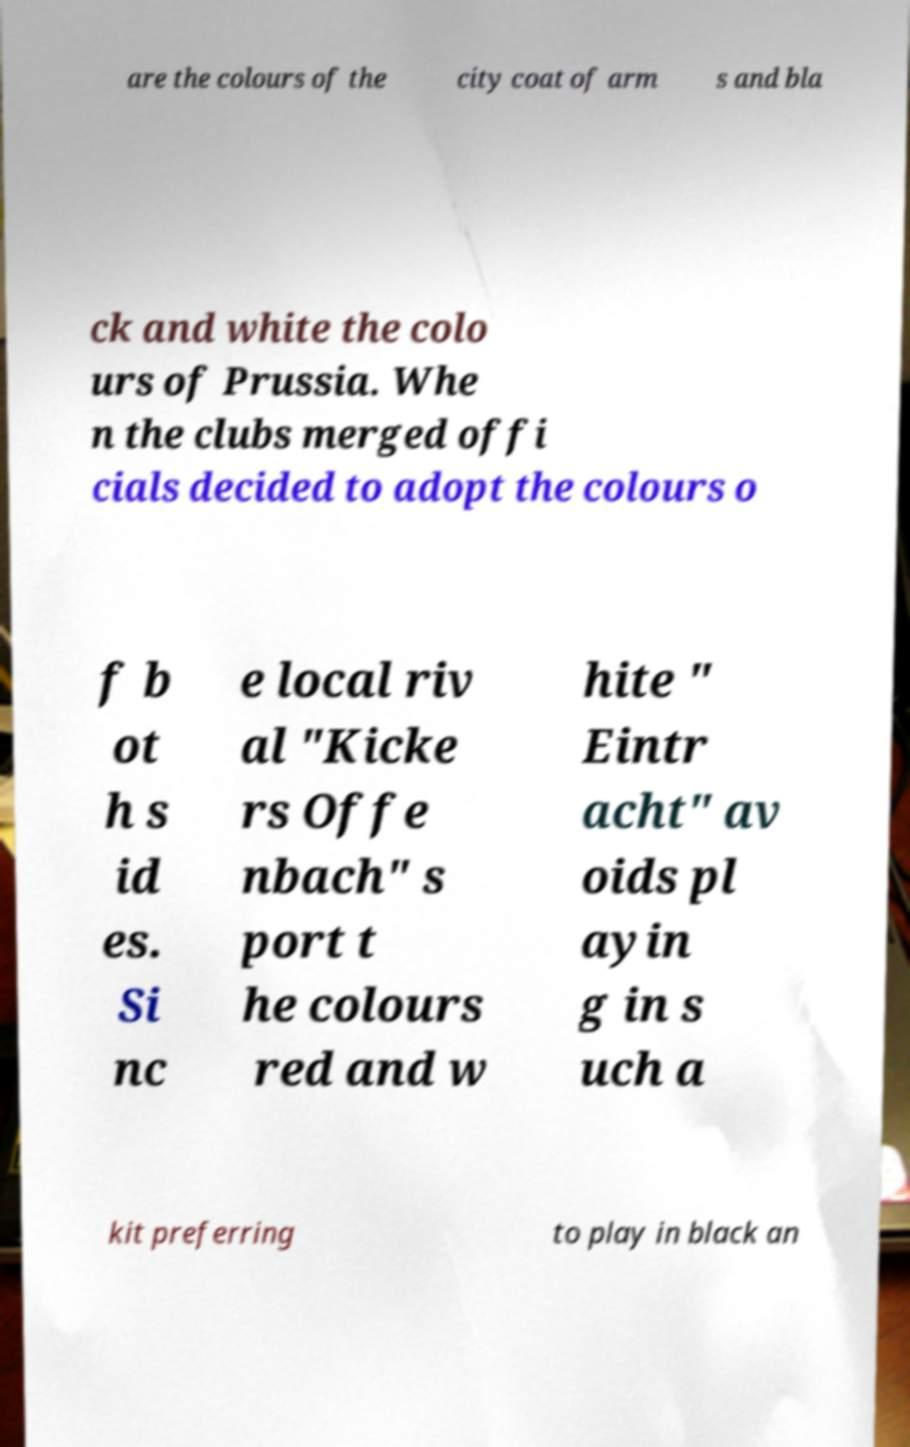What messages or text are displayed in this image? I need them in a readable, typed format. are the colours of the city coat of arm s and bla ck and white the colo urs of Prussia. Whe n the clubs merged offi cials decided to adopt the colours o f b ot h s id es. Si nc e local riv al "Kicke rs Offe nbach" s port t he colours red and w hite " Eintr acht" av oids pl ayin g in s uch a kit preferring to play in black an 